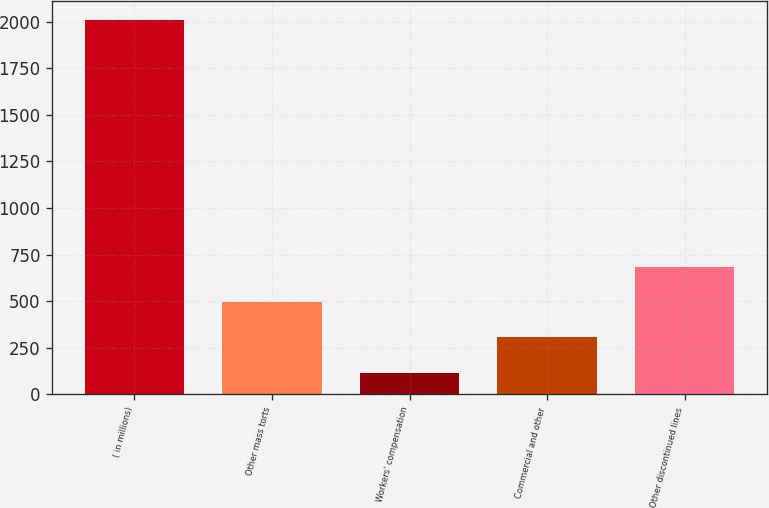<chart> <loc_0><loc_0><loc_500><loc_500><bar_chart><fcel>( in millions)<fcel>Other mass torts<fcel>Workers' compensation<fcel>Commercial and other<fcel>Other discontinued lines<nl><fcel>2010<fcel>494.8<fcel>116<fcel>305.4<fcel>684.2<nl></chart> 